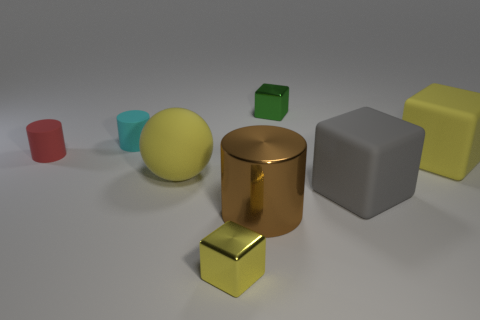Is the number of large yellow objects that are to the right of the yellow ball greater than the number of brown shiny cylinders?
Give a very brief answer. No. Is the green metallic cube the same size as the brown cylinder?
Provide a succinct answer. No. There is another small object that is made of the same material as the green object; what is its color?
Provide a succinct answer. Yellow. The tiny metallic thing that is the same color as the matte ball is what shape?
Give a very brief answer. Cube. Are there an equal number of green metallic objects to the left of the small red object and big gray things that are in front of the large yellow matte block?
Keep it short and to the point. No. What shape is the big yellow matte object to the left of the small metallic thing that is to the right of the metal cylinder?
Offer a terse response. Sphere. What material is the large object that is the same shape as the small cyan thing?
Keep it short and to the point. Metal. What color is the other metallic block that is the same size as the green cube?
Your response must be concise. Yellow. Is the number of yellow matte spheres that are behind the cyan rubber cylinder the same as the number of green blocks?
Offer a terse response. No. What is the color of the tiny shiny thing behind the big yellow rubber object that is to the right of the big brown cylinder?
Ensure brevity in your answer.  Green. 